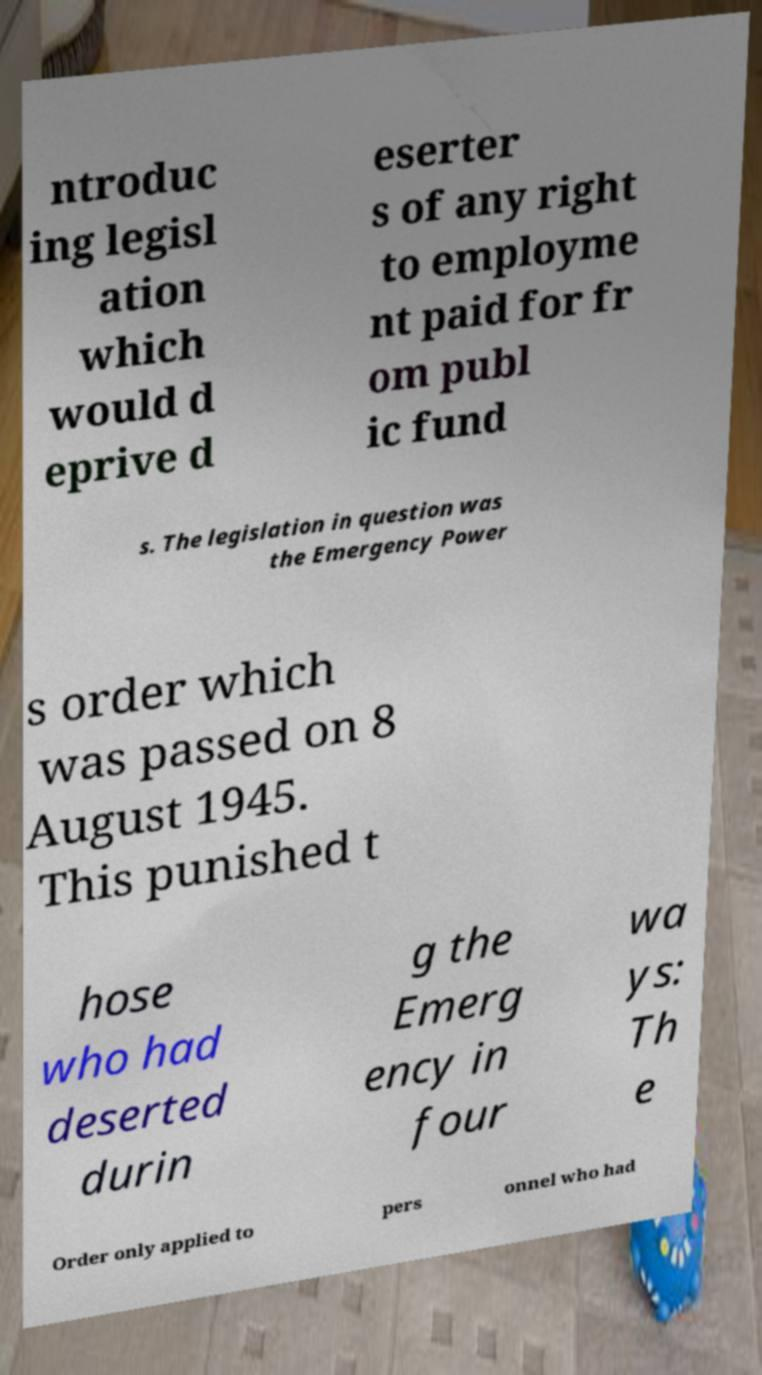Please read and relay the text visible in this image. What does it say? ntroduc ing legisl ation which would d eprive d eserter s of any right to employme nt paid for fr om publ ic fund s. The legislation in question was the Emergency Power s order which was passed on 8 August 1945. This punished t hose who had deserted durin g the Emerg ency in four wa ys: Th e Order only applied to pers onnel who had 